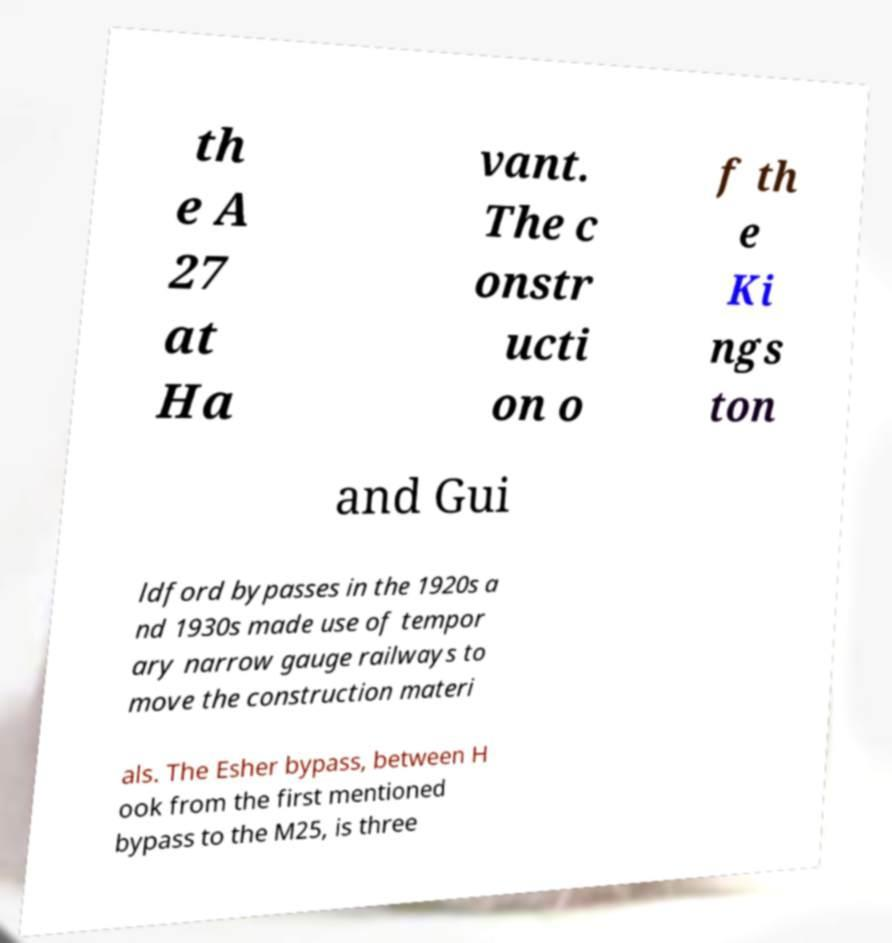There's text embedded in this image that I need extracted. Can you transcribe it verbatim? th e A 27 at Ha vant. The c onstr ucti on o f th e Ki ngs ton and Gui ldford bypasses in the 1920s a nd 1930s made use of tempor ary narrow gauge railways to move the construction materi als. The Esher bypass, between H ook from the first mentioned bypass to the M25, is three 